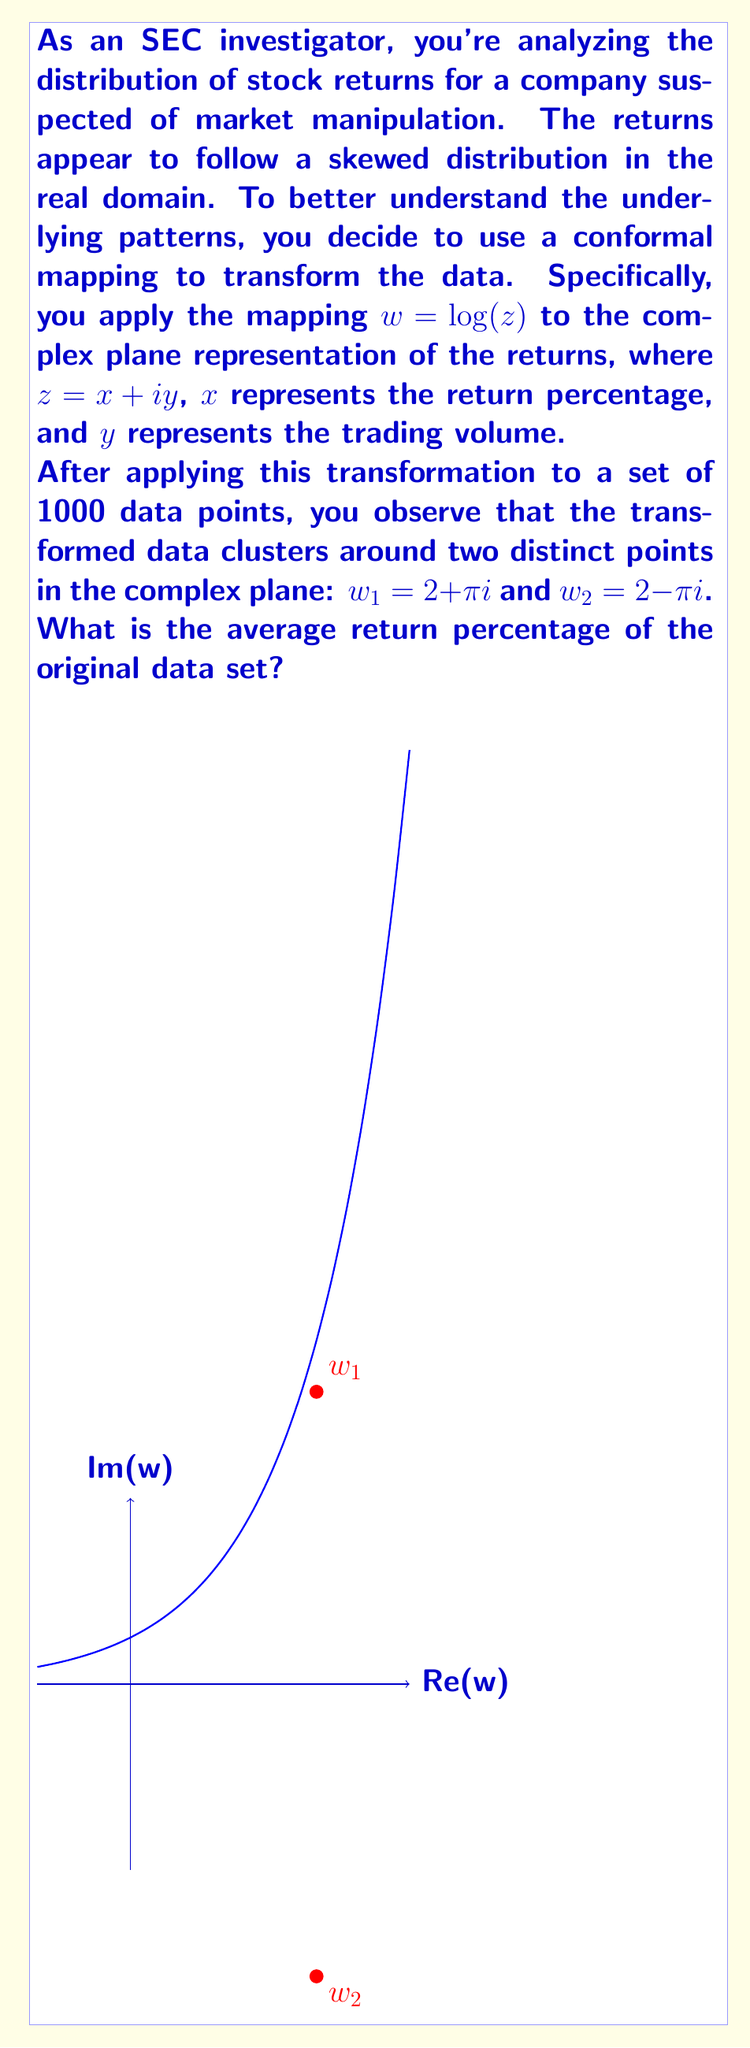Could you help me with this problem? Let's approach this step-by-step:

1) The conformal mapping used is $w = \log(z)$, where $z = x + iy$.

2) Given that the transformed data clusters around $w_1 = 2 + \pi i$ and $w_2 = 2 - \pi i$, we can infer that these are the two main concentrations of data after transformation.

3) To find the original values, we need to apply the inverse transformation:
   $z = e^w$

4) For $w_1 = 2 + \pi i$:
   $z_1 = e^{2 + \pi i} = e^2 (\cos \pi + i \sin \pi) = -e^2$

5) For $w_2 = 2 - \pi i$:
   $z_2 = e^{2 - \pi i} = e^2 (\cos (-\pi) + i \sin (-\pi)) = -e^2$

6) Note that both $z_1$ and $z_2$ result in the same value in the real domain: $-e^2$

7) Recall that in our original data, $x$ represented the return percentage. Therefore, the return percentage corresponding to these clustered points is $-e^2$.

8) To convert this to a percentage, we subtract 1 and multiply by 100:
   Return percentage = $(-e^2 - 1) * 100\% \approx 638.9\%$

9) Since the data clusters around these two points after transformation, we can infer that the original data was concentrated around this return percentage.

Therefore, the average return percentage of the original data set is approximately 638.9%.
Answer: 638.9% 